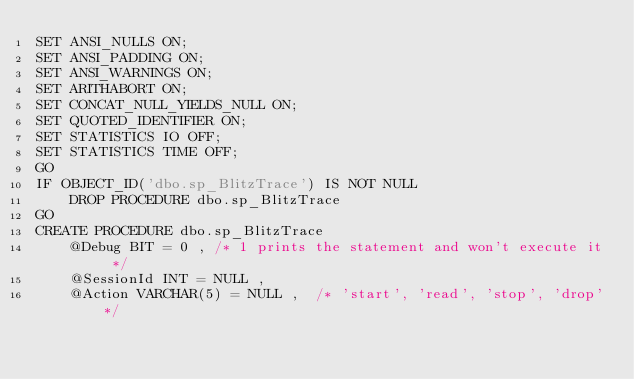<code> <loc_0><loc_0><loc_500><loc_500><_SQL_>SET ANSI_NULLS ON;
SET ANSI_PADDING ON;
SET ANSI_WARNINGS ON;
SET ARITHABORT ON;
SET CONCAT_NULL_YIELDS_NULL ON;
SET QUOTED_IDENTIFIER ON;
SET STATISTICS IO OFF;
SET STATISTICS TIME OFF;
GO
IF OBJECT_ID('dbo.sp_BlitzTrace') IS NOT NULL
    DROP PROCEDURE dbo.sp_BlitzTrace
GO
CREATE PROCEDURE dbo.sp_BlitzTrace
    @Debug BIT = 0 , /* 1 prints the statement and won't execute it */
    @SessionId INT = NULL ,
    @Action VARCHAR(5) = NULL ,  /* 'start', 'read', 'stop', 'drop'*/</code> 